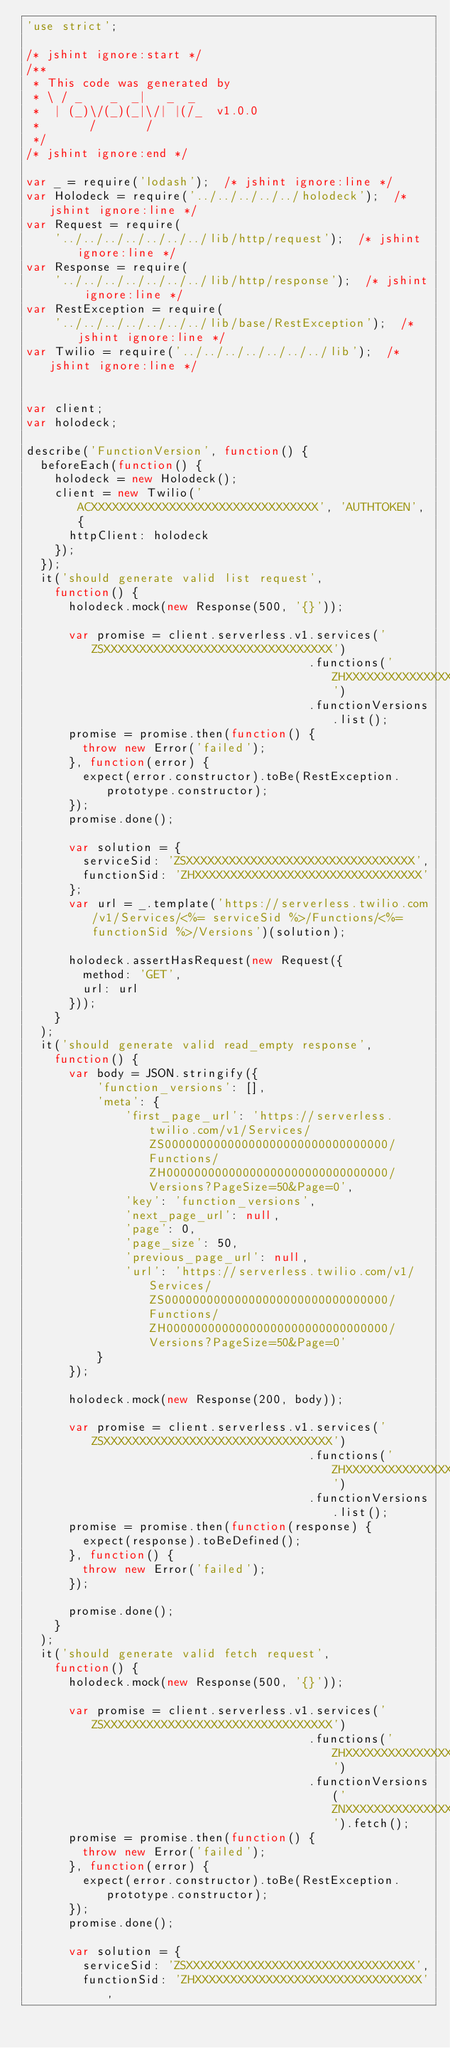Convert code to text. <code><loc_0><loc_0><loc_500><loc_500><_JavaScript_>'use strict';

/* jshint ignore:start */
/**
 * This code was generated by
 * \ / _    _  _|   _  _
 *  | (_)\/(_)(_|\/| |(/_  v1.0.0
 *       /       /
 */
/* jshint ignore:end */

var _ = require('lodash');  /* jshint ignore:line */
var Holodeck = require('../../../../../holodeck');  /* jshint ignore:line */
var Request = require(
    '../../../../../../../lib/http/request');  /* jshint ignore:line */
var Response = require(
    '../../../../../../../lib/http/response');  /* jshint ignore:line */
var RestException = require(
    '../../../../../../../lib/base/RestException');  /* jshint ignore:line */
var Twilio = require('../../../../../../../lib');  /* jshint ignore:line */


var client;
var holodeck;

describe('FunctionVersion', function() {
  beforeEach(function() {
    holodeck = new Holodeck();
    client = new Twilio('ACXXXXXXXXXXXXXXXXXXXXXXXXXXXXXXXX', 'AUTHTOKEN', {
      httpClient: holodeck
    });
  });
  it('should generate valid list request',
    function() {
      holodeck.mock(new Response(500, '{}'));

      var promise = client.serverless.v1.services('ZSXXXXXXXXXXXXXXXXXXXXXXXXXXXXXXXX')
                                        .functions('ZHXXXXXXXXXXXXXXXXXXXXXXXXXXXXXXXX')
                                        .functionVersions.list();
      promise = promise.then(function() {
        throw new Error('failed');
      }, function(error) {
        expect(error.constructor).toBe(RestException.prototype.constructor);
      });
      promise.done();

      var solution = {
        serviceSid: 'ZSXXXXXXXXXXXXXXXXXXXXXXXXXXXXXXXX',
        functionSid: 'ZHXXXXXXXXXXXXXXXXXXXXXXXXXXXXXXXX'
      };
      var url = _.template('https://serverless.twilio.com/v1/Services/<%= serviceSid %>/Functions/<%= functionSid %>/Versions')(solution);

      holodeck.assertHasRequest(new Request({
        method: 'GET',
        url: url
      }));
    }
  );
  it('should generate valid read_empty response',
    function() {
      var body = JSON.stringify({
          'function_versions': [],
          'meta': {
              'first_page_url': 'https://serverless.twilio.com/v1/Services/ZS00000000000000000000000000000000/Functions/ZH00000000000000000000000000000000/Versions?PageSize=50&Page=0',
              'key': 'function_versions',
              'next_page_url': null,
              'page': 0,
              'page_size': 50,
              'previous_page_url': null,
              'url': 'https://serverless.twilio.com/v1/Services/ZS00000000000000000000000000000000/Functions/ZH00000000000000000000000000000000/Versions?PageSize=50&Page=0'
          }
      });

      holodeck.mock(new Response(200, body));

      var promise = client.serverless.v1.services('ZSXXXXXXXXXXXXXXXXXXXXXXXXXXXXXXXX')
                                        .functions('ZHXXXXXXXXXXXXXXXXXXXXXXXXXXXXXXXX')
                                        .functionVersions.list();
      promise = promise.then(function(response) {
        expect(response).toBeDefined();
      }, function() {
        throw new Error('failed');
      });

      promise.done();
    }
  );
  it('should generate valid fetch request',
    function() {
      holodeck.mock(new Response(500, '{}'));

      var promise = client.serverless.v1.services('ZSXXXXXXXXXXXXXXXXXXXXXXXXXXXXXXXX')
                                        .functions('ZHXXXXXXXXXXXXXXXXXXXXXXXXXXXXXXXX')
                                        .functionVersions('ZNXXXXXXXXXXXXXXXXXXXXXXXXXXXXXXXX').fetch();
      promise = promise.then(function() {
        throw new Error('failed');
      }, function(error) {
        expect(error.constructor).toBe(RestException.prototype.constructor);
      });
      promise.done();

      var solution = {
        serviceSid: 'ZSXXXXXXXXXXXXXXXXXXXXXXXXXXXXXXXX',
        functionSid: 'ZHXXXXXXXXXXXXXXXXXXXXXXXXXXXXXXXX',</code> 